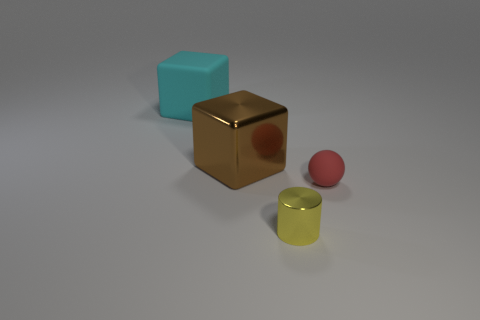Add 2 tiny yellow cylinders. How many objects exist? 6 Subtract all balls. How many objects are left? 3 Subtract 0 red cylinders. How many objects are left? 4 Subtract all large blue rubber balls. Subtract all big cyan rubber things. How many objects are left? 3 Add 1 big brown shiny cubes. How many big brown shiny cubes are left? 2 Add 4 matte spheres. How many matte spheres exist? 5 